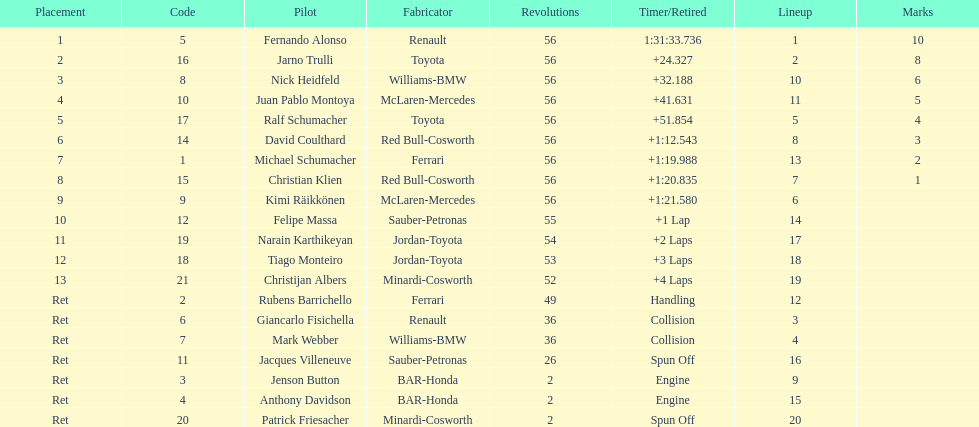Which british driver last managed to finish the entire 56 laps? David Coulthard. 